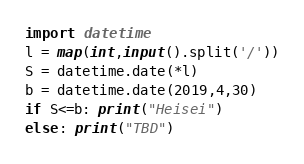Convert code to text. <code><loc_0><loc_0><loc_500><loc_500><_Python_>import datetime
l = map(int,input().split('/'))
S = datetime.date(*l)
b = datetime.date(2019,4,30)
if S<=b: print("Heisei")
else: print("TBD")</code> 